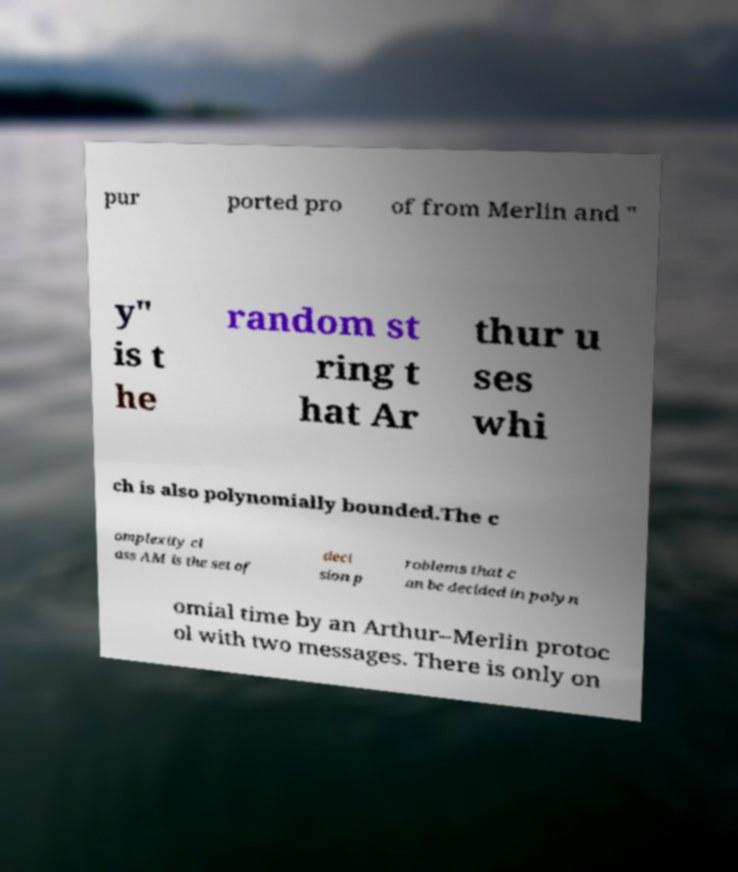Could you assist in decoding the text presented in this image and type it out clearly? pur ported pro of from Merlin and " y" is t he random st ring t hat Ar thur u ses whi ch is also polynomially bounded.The c omplexity cl ass AM is the set of deci sion p roblems that c an be decided in polyn omial time by an Arthur–Merlin protoc ol with two messages. There is only on 